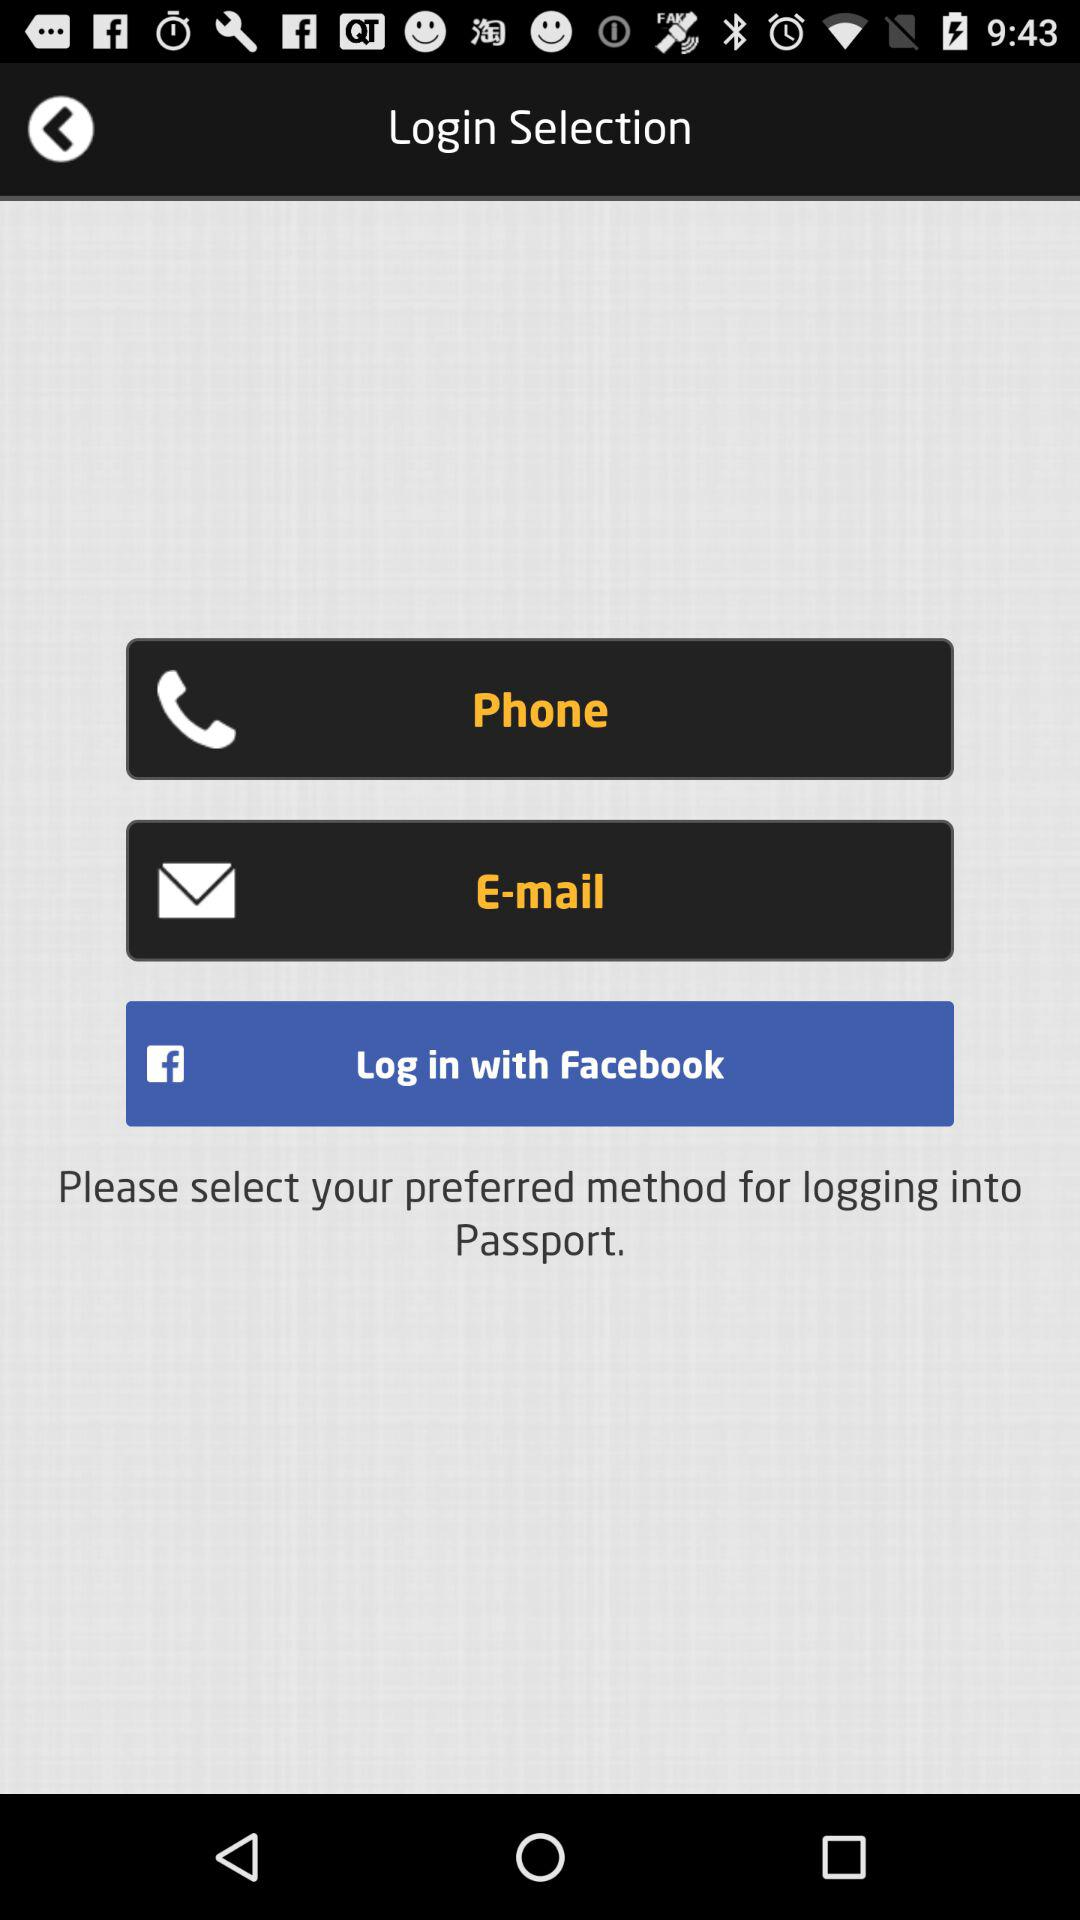What do we need to select for logging into Passport? You need to select your preferred method for logging into Passport. 